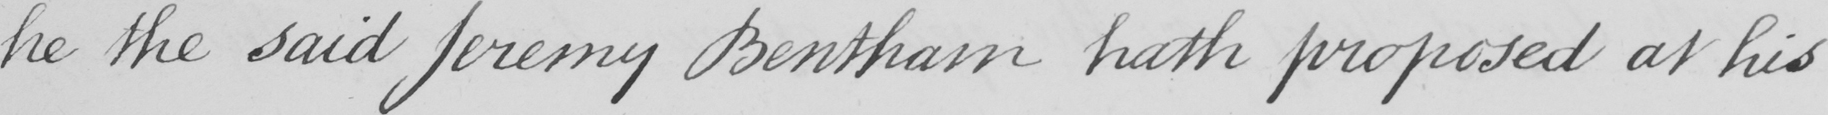What is written in this line of handwriting? he the said Jeremy Bentham hath proposed at his 